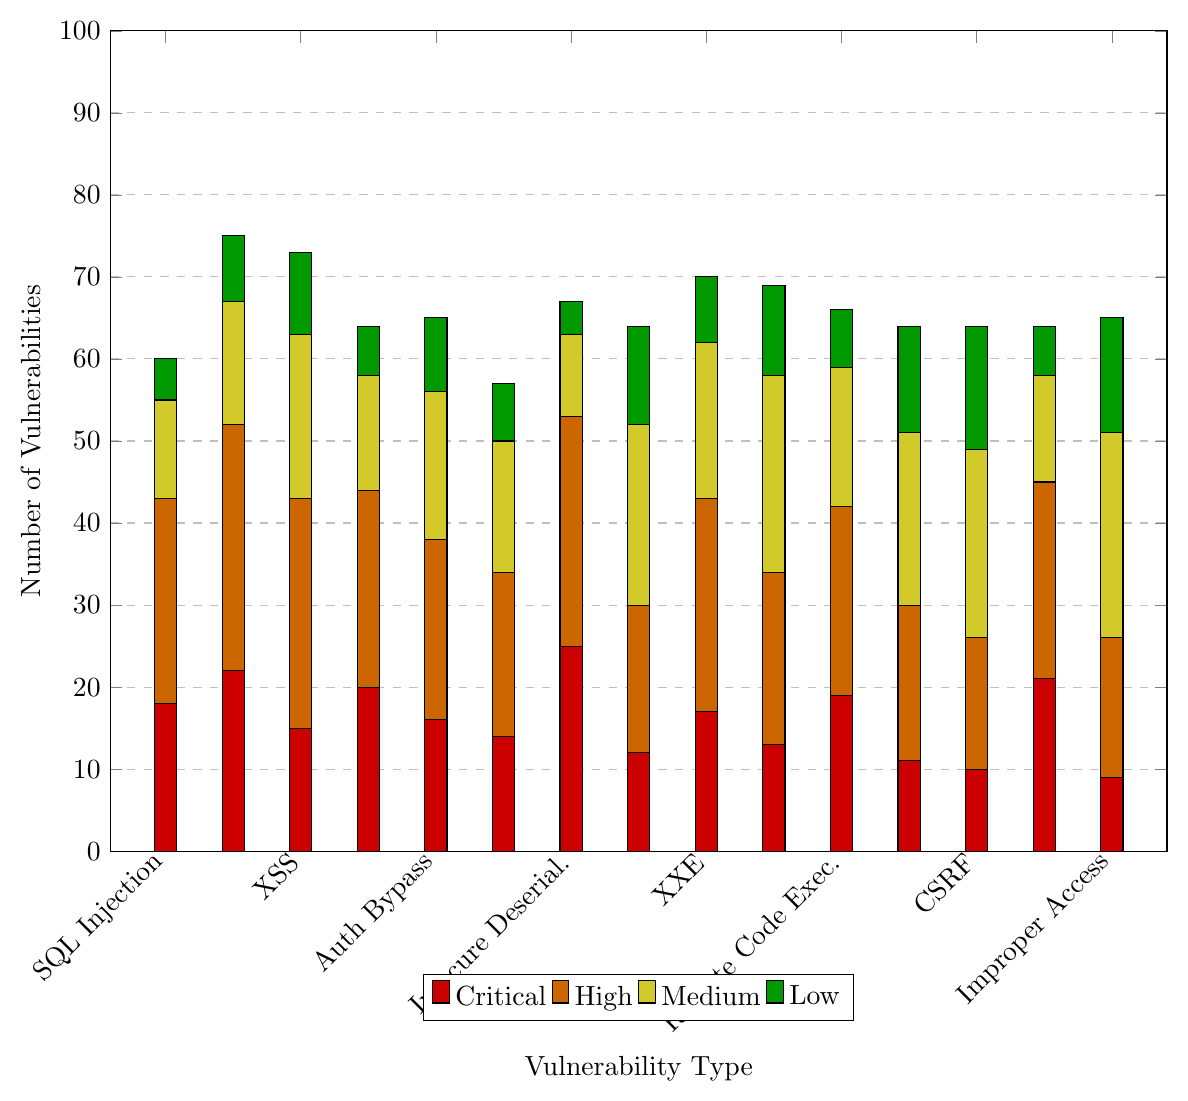Which vulnerability type has the highest number of Critical severity cases? The tallest red bar represents the vulnerability type with the highest number of Critical severity cases. By observing the chart, "Remote Code Execution" has the tallest red bar, indicating the highest number.
Answer: Remote Code Execution What is the total number of vulnerabilities for SQL Injection across all severity levels? Sum the heights of all the bars corresponding to "SQL Injection." These are the bars for Critical (22), High (30), Medium (15), and Low (8). So, the total is 22 + 30 + 15 + 8 = 75.
Answer: 75 Which severity level has the most cases of Cross-Site Scripting (XSS)? Look at the heights of the bars associated with "Cross-Site Scripting (XSS)" for each severity level. The highest one is orange (High), indicating the most cases.
Answer: High Compare the number of Medium and Low vulnerabilities for Race Condition. Which is greater, and by how much? The height of the yellow bar for Medium in Race Condition is 23, and the height of the green bar for Low is 15. The difference is 23 - 15 = 8, with Medium being greater.
Answer: Medium by 8 Is the number of Insecure Deserialization vulnerabilities more than the number of Directory Traversal vulnerabilities at the Medium severity level? Compare the heights of the yellow bars for "Insecure Deserialization" (18) and "Directory Traversal" (21). Directory Traversal has a taller bar, indicating a higher number.
Answer: No Which vulnerability type has a higher count of High severity cases: Insecure Deserialization or Improper Access Control? Compare the heights of the orange bars for "Insecure Deserialization" (22) and "Improper Access Control" (26). Improper Access Control has a taller bar, indicating a higher count.
Answer: Improper Access Control What's the average number of Critical vulnerabilities across all types? Sum the heights of all the red bars for each vulnerability type and divide by the number of types (15): (18 + 22 + 15 + 20 + 16 + 14 + 25 + 12 + 17 + 13 + 19 + 11 + 10 + 21 + 9) / 15 = 246 / 15 = 16.4.
Answer: 16.4 For which vulnerability type are Low severity cases more prevalent than Medium severity cases? Compare the heights of green bars (Low) and yellow bars (Medium) for each type. "Race Condition" has a green bar (15) taller than the yellow bar (13).
Answer: Race Condition 